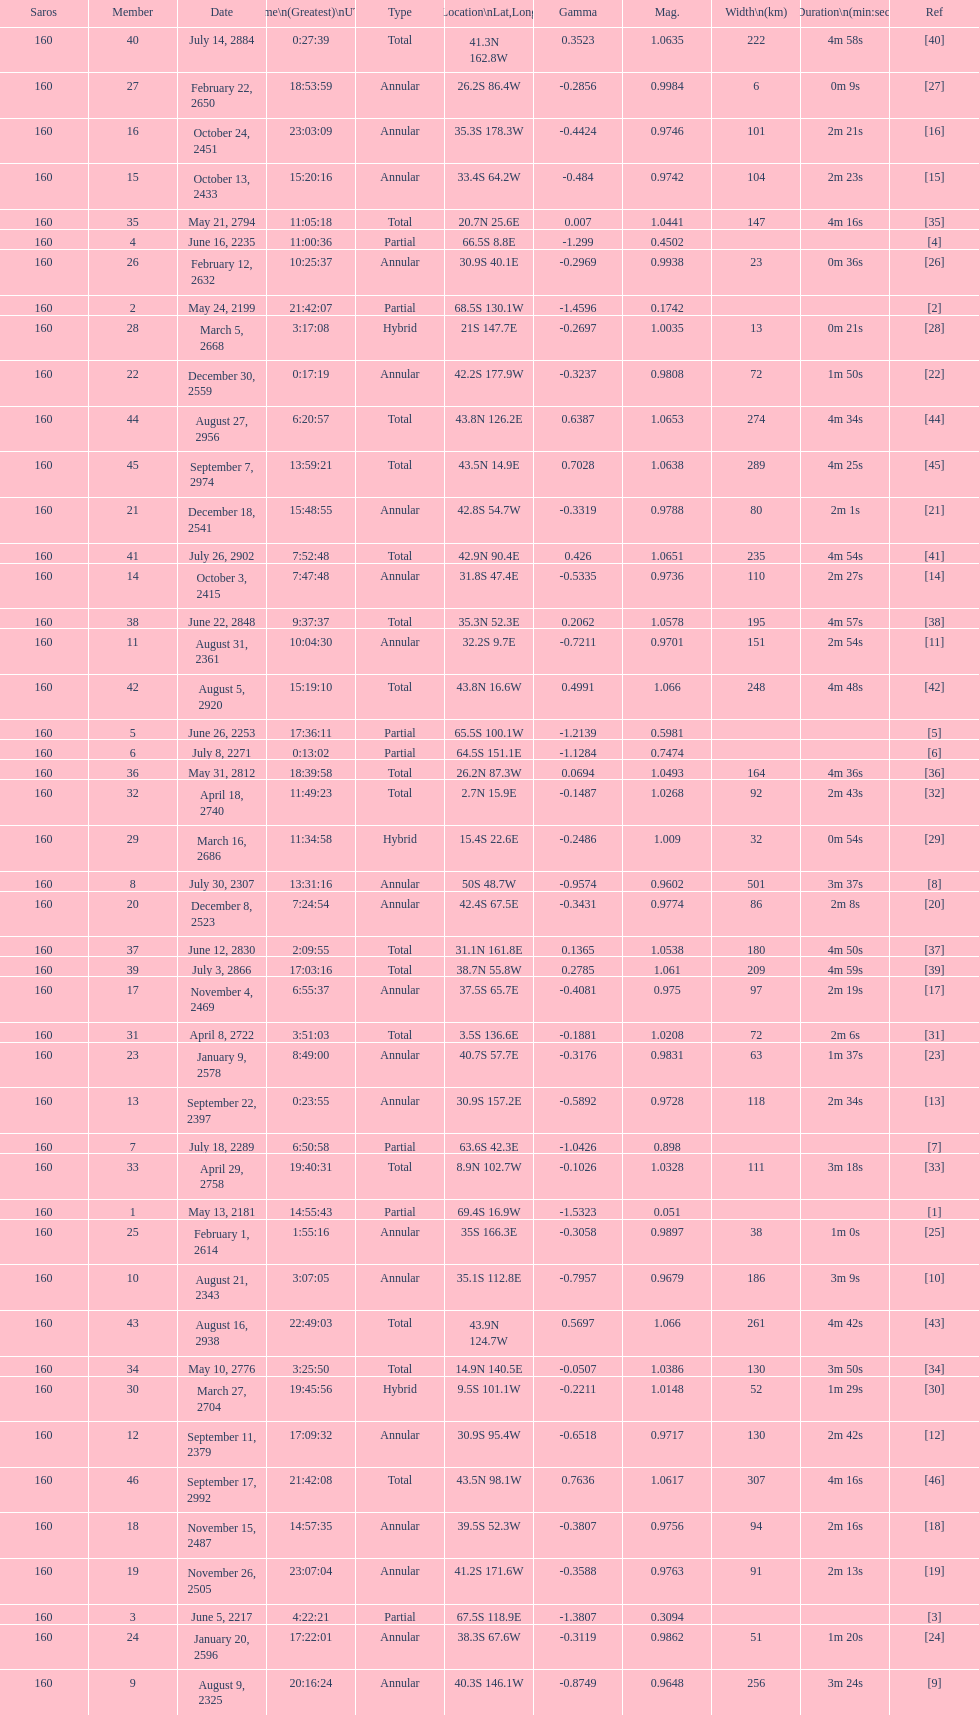What is the previous time for the saros on october 3, 2415? 7:47:48. 